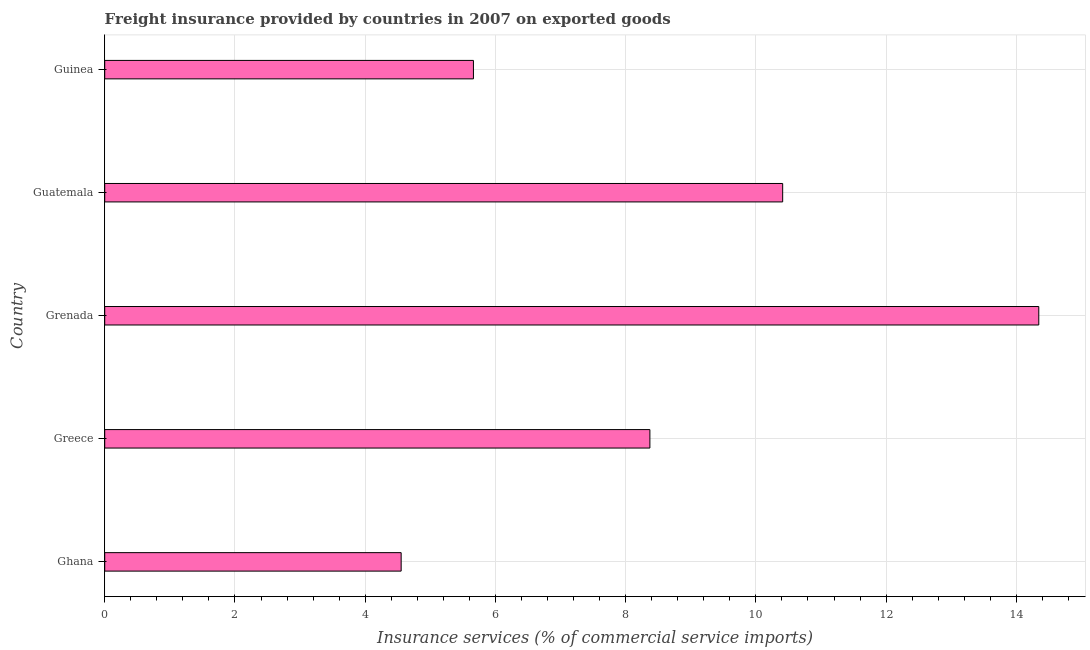Does the graph contain any zero values?
Ensure brevity in your answer.  No. What is the title of the graph?
Make the answer very short. Freight insurance provided by countries in 2007 on exported goods . What is the label or title of the X-axis?
Provide a succinct answer. Insurance services (% of commercial service imports). What is the freight insurance in Guatemala?
Make the answer very short. 10.41. Across all countries, what is the maximum freight insurance?
Keep it short and to the point. 14.34. Across all countries, what is the minimum freight insurance?
Your response must be concise. 4.55. In which country was the freight insurance maximum?
Provide a succinct answer. Grenada. What is the sum of the freight insurance?
Give a very brief answer. 43.34. What is the difference between the freight insurance in Ghana and Guinea?
Offer a terse response. -1.11. What is the average freight insurance per country?
Offer a very short reply. 8.67. What is the median freight insurance?
Keep it short and to the point. 8.37. In how many countries, is the freight insurance greater than 13.6 %?
Offer a terse response. 1. What is the ratio of the freight insurance in Ghana to that in Guatemala?
Offer a very short reply. 0.44. Is the freight insurance in Greece less than that in Grenada?
Your answer should be very brief. Yes. What is the difference between the highest and the second highest freight insurance?
Give a very brief answer. 3.93. What is the difference between the highest and the lowest freight insurance?
Provide a short and direct response. 9.79. What is the difference between two consecutive major ticks on the X-axis?
Your answer should be compact. 2. Are the values on the major ticks of X-axis written in scientific E-notation?
Give a very brief answer. No. What is the Insurance services (% of commercial service imports) of Ghana?
Provide a short and direct response. 4.55. What is the Insurance services (% of commercial service imports) in Greece?
Keep it short and to the point. 8.37. What is the Insurance services (% of commercial service imports) of Grenada?
Make the answer very short. 14.34. What is the Insurance services (% of commercial service imports) in Guatemala?
Offer a terse response. 10.41. What is the Insurance services (% of commercial service imports) in Guinea?
Your response must be concise. 5.66. What is the difference between the Insurance services (% of commercial service imports) in Ghana and Greece?
Your response must be concise. -3.82. What is the difference between the Insurance services (% of commercial service imports) in Ghana and Grenada?
Keep it short and to the point. -9.79. What is the difference between the Insurance services (% of commercial service imports) in Ghana and Guatemala?
Your response must be concise. -5.86. What is the difference between the Insurance services (% of commercial service imports) in Ghana and Guinea?
Give a very brief answer. -1.11. What is the difference between the Insurance services (% of commercial service imports) in Greece and Grenada?
Your answer should be very brief. -5.97. What is the difference between the Insurance services (% of commercial service imports) in Greece and Guatemala?
Provide a short and direct response. -2.04. What is the difference between the Insurance services (% of commercial service imports) in Greece and Guinea?
Your answer should be compact. 2.71. What is the difference between the Insurance services (% of commercial service imports) in Grenada and Guatemala?
Provide a short and direct response. 3.93. What is the difference between the Insurance services (% of commercial service imports) in Grenada and Guinea?
Give a very brief answer. 8.68. What is the difference between the Insurance services (% of commercial service imports) in Guatemala and Guinea?
Ensure brevity in your answer.  4.75. What is the ratio of the Insurance services (% of commercial service imports) in Ghana to that in Greece?
Offer a very short reply. 0.54. What is the ratio of the Insurance services (% of commercial service imports) in Ghana to that in Grenada?
Provide a succinct answer. 0.32. What is the ratio of the Insurance services (% of commercial service imports) in Ghana to that in Guatemala?
Your answer should be compact. 0.44. What is the ratio of the Insurance services (% of commercial service imports) in Ghana to that in Guinea?
Keep it short and to the point. 0.8. What is the ratio of the Insurance services (% of commercial service imports) in Greece to that in Grenada?
Offer a very short reply. 0.58. What is the ratio of the Insurance services (% of commercial service imports) in Greece to that in Guatemala?
Make the answer very short. 0.8. What is the ratio of the Insurance services (% of commercial service imports) in Greece to that in Guinea?
Make the answer very short. 1.48. What is the ratio of the Insurance services (% of commercial service imports) in Grenada to that in Guatemala?
Keep it short and to the point. 1.38. What is the ratio of the Insurance services (% of commercial service imports) in Grenada to that in Guinea?
Keep it short and to the point. 2.53. What is the ratio of the Insurance services (% of commercial service imports) in Guatemala to that in Guinea?
Your response must be concise. 1.84. 